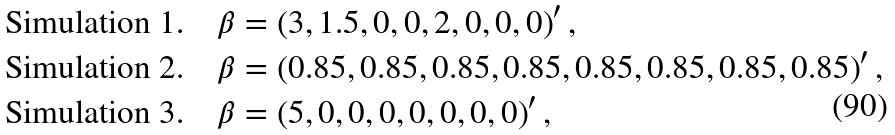Convert formula to latex. <formula><loc_0><loc_0><loc_500><loc_500>\text {Simulation 1.} \quad & \beta = \left ( 3 , 1 . 5 , 0 , 0 , 2 , 0 , 0 , 0 \right ) ^ { \prime } , \\ \text {Simulation 2.} \quad & \beta = \left ( 0 . 8 5 , 0 . 8 5 , 0 . 8 5 , 0 . 8 5 , 0 . 8 5 , 0 . 8 5 , 0 . 8 5 , 0 . 8 5 \right ) ^ { \prime } , \\ \text {Simulation 3.} \quad & \beta = \left ( 5 , 0 , 0 , 0 , 0 , 0 , 0 , 0 \right ) ^ { \prime } ,</formula> 